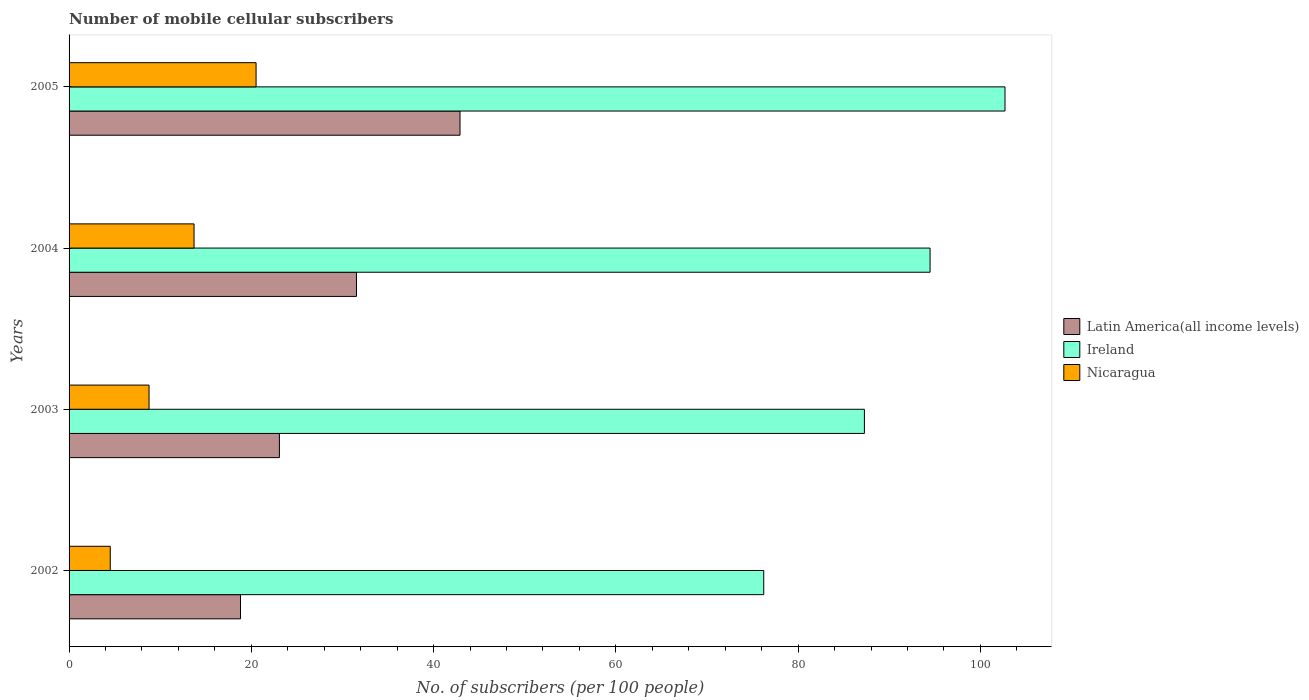How many groups of bars are there?
Make the answer very short. 4. How many bars are there on the 1st tick from the bottom?
Your answer should be very brief. 3. In how many cases, is the number of bars for a given year not equal to the number of legend labels?
Provide a short and direct response. 0. What is the number of mobile cellular subscribers in Nicaragua in 2004?
Keep it short and to the point. 13.71. Across all years, what is the maximum number of mobile cellular subscribers in Latin America(all income levels)?
Offer a very short reply. 42.9. Across all years, what is the minimum number of mobile cellular subscribers in Nicaragua?
Ensure brevity in your answer.  4.52. In which year was the number of mobile cellular subscribers in Ireland minimum?
Your answer should be compact. 2002. What is the total number of mobile cellular subscribers in Ireland in the graph?
Your answer should be very brief. 360.66. What is the difference between the number of mobile cellular subscribers in Nicaragua in 2002 and that in 2003?
Keep it short and to the point. -4.26. What is the difference between the number of mobile cellular subscribers in Latin America(all income levels) in 2004 and the number of mobile cellular subscribers in Ireland in 2003?
Ensure brevity in your answer.  -55.73. What is the average number of mobile cellular subscribers in Nicaragua per year?
Your answer should be very brief. 11.88. In the year 2004, what is the difference between the number of mobile cellular subscribers in Nicaragua and number of mobile cellular subscribers in Ireland?
Offer a terse response. -80.76. In how many years, is the number of mobile cellular subscribers in Ireland greater than 92 ?
Provide a succinct answer. 2. What is the ratio of the number of mobile cellular subscribers in Nicaragua in 2003 to that in 2005?
Your answer should be very brief. 0.43. Is the number of mobile cellular subscribers in Latin America(all income levels) in 2004 less than that in 2005?
Offer a very short reply. Yes. What is the difference between the highest and the second highest number of mobile cellular subscribers in Nicaragua?
Provide a succinct answer. 6.81. What is the difference between the highest and the lowest number of mobile cellular subscribers in Ireland?
Offer a terse response. 26.47. In how many years, is the number of mobile cellular subscribers in Latin America(all income levels) greater than the average number of mobile cellular subscribers in Latin America(all income levels) taken over all years?
Offer a very short reply. 2. Is the sum of the number of mobile cellular subscribers in Latin America(all income levels) in 2002 and 2004 greater than the maximum number of mobile cellular subscribers in Ireland across all years?
Provide a succinct answer. No. What does the 1st bar from the top in 2003 represents?
Offer a very short reply. Nicaragua. What does the 1st bar from the bottom in 2003 represents?
Offer a very short reply. Latin America(all income levels). Are all the bars in the graph horizontal?
Give a very brief answer. Yes. How many years are there in the graph?
Your answer should be compact. 4. Does the graph contain any zero values?
Provide a short and direct response. No. How many legend labels are there?
Ensure brevity in your answer.  3. How are the legend labels stacked?
Ensure brevity in your answer.  Vertical. What is the title of the graph?
Keep it short and to the point. Number of mobile cellular subscribers. What is the label or title of the X-axis?
Provide a short and direct response. No. of subscribers (per 100 people). What is the label or title of the Y-axis?
Keep it short and to the point. Years. What is the No. of subscribers (per 100 people) in Latin America(all income levels) in 2002?
Give a very brief answer. 18.81. What is the No. of subscribers (per 100 people) of Ireland in 2002?
Provide a succinct answer. 76.22. What is the No. of subscribers (per 100 people) in Nicaragua in 2002?
Provide a short and direct response. 4.52. What is the No. of subscribers (per 100 people) of Latin America(all income levels) in 2003?
Offer a terse response. 23.08. What is the No. of subscribers (per 100 people) of Ireland in 2003?
Ensure brevity in your answer.  87.27. What is the No. of subscribers (per 100 people) in Nicaragua in 2003?
Offer a terse response. 8.78. What is the No. of subscribers (per 100 people) in Latin America(all income levels) in 2004?
Give a very brief answer. 31.54. What is the No. of subscribers (per 100 people) in Ireland in 2004?
Provide a short and direct response. 94.47. What is the No. of subscribers (per 100 people) in Nicaragua in 2004?
Offer a terse response. 13.71. What is the No. of subscribers (per 100 people) in Latin America(all income levels) in 2005?
Your answer should be very brief. 42.9. What is the No. of subscribers (per 100 people) in Ireland in 2005?
Make the answer very short. 102.69. What is the No. of subscribers (per 100 people) in Nicaragua in 2005?
Provide a short and direct response. 20.52. Across all years, what is the maximum No. of subscribers (per 100 people) of Latin America(all income levels)?
Provide a succinct answer. 42.9. Across all years, what is the maximum No. of subscribers (per 100 people) of Ireland?
Your answer should be compact. 102.69. Across all years, what is the maximum No. of subscribers (per 100 people) in Nicaragua?
Provide a succinct answer. 20.52. Across all years, what is the minimum No. of subscribers (per 100 people) in Latin America(all income levels)?
Your answer should be very brief. 18.81. Across all years, what is the minimum No. of subscribers (per 100 people) of Ireland?
Provide a short and direct response. 76.22. Across all years, what is the minimum No. of subscribers (per 100 people) of Nicaragua?
Offer a very short reply. 4.52. What is the total No. of subscribers (per 100 people) in Latin America(all income levels) in the graph?
Provide a short and direct response. 116.32. What is the total No. of subscribers (per 100 people) in Ireland in the graph?
Your answer should be compact. 360.66. What is the total No. of subscribers (per 100 people) of Nicaragua in the graph?
Your answer should be compact. 47.53. What is the difference between the No. of subscribers (per 100 people) of Latin America(all income levels) in 2002 and that in 2003?
Your answer should be compact. -4.27. What is the difference between the No. of subscribers (per 100 people) of Ireland in 2002 and that in 2003?
Keep it short and to the point. -11.05. What is the difference between the No. of subscribers (per 100 people) of Nicaragua in 2002 and that in 2003?
Ensure brevity in your answer.  -4.26. What is the difference between the No. of subscribers (per 100 people) in Latin America(all income levels) in 2002 and that in 2004?
Your answer should be compact. -12.73. What is the difference between the No. of subscribers (per 100 people) of Ireland in 2002 and that in 2004?
Your answer should be compact. -18.25. What is the difference between the No. of subscribers (per 100 people) of Nicaragua in 2002 and that in 2004?
Give a very brief answer. -9.19. What is the difference between the No. of subscribers (per 100 people) of Latin America(all income levels) in 2002 and that in 2005?
Make the answer very short. -24.09. What is the difference between the No. of subscribers (per 100 people) of Ireland in 2002 and that in 2005?
Ensure brevity in your answer.  -26.47. What is the difference between the No. of subscribers (per 100 people) of Nicaragua in 2002 and that in 2005?
Give a very brief answer. -16. What is the difference between the No. of subscribers (per 100 people) in Latin America(all income levels) in 2003 and that in 2004?
Your answer should be compact. -8.46. What is the difference between the No. of subscribers (per 100 people) in Ireland in 2003 and that in 2004?
Offer a terse response. -7.21. What is the difference between the No. of subscribers (per 100 people) in Nicaragua in 2003 and that in 2004?
Keep it short and to the point. -4.94. What is the difference between the No. of subscribers (per 100 people) in Latin America(all income levels) in 2003 and that in 2005?
Offer a terse response. -19.82. What is the difference between the No. of subscribers (per 100 people) in Ireland in 2003 and that in 2005?
Your answer should be compact. -15.43. What is the difference between the No. of subscribers (per 100 people) of Nicaragua in 2003 and that in 2005?
Offer a very short reply. -11.74. What is the difference between the No. of subscribers (per 100 people) in Latin America(all income levels) in 2004 and that in 2005?
Provide a succinct answer. -11.36. What is the difference between the No. of subscribers (per 100 people) of Ireland in 2004 and that in 2005?
Provide a succinct answer. -8.22. What is the difference between the No. of subscribers (per 100 people) of Nicaragua in 2004 and that in 2005?
Give a very brief answer. -6.81. What is the difference between the No. of subscribers (per 100 people) in Latin America(all income levels) in 2002 and the No. of subscribers (per 100 people) in Ireland in 2003?
Your response must be concise. -68.46. What is the difference between the No. of subscribers (per 100 people) in Latin America(all income levels) in 2002 and the No. of subscribers (per 100 people) in Nicaragua in 2003?
Give a very brief answer. 10.03. What is the difference between the No. of subscribers (per 100 people) in Ireland in 2002 and the No. of subscribers (per 100 people) in Nicaragua in 2003?
Offer a terse response. 67.45. What is the difference between the No. of subscribers (per 100 people) of Latin America(all income levels) in 2002 and the No. of subscribers (per 100 people) of Ireland in 2004?
Your response must be concise. -75.66. What is the difference between the No. of subscribers (per 100 people) in Latin America(all income levels) in 2002 and the No. of subscribers (per 100 people) in Nicaragua in 2004?
Your response must be concise. 5.1. What is the difference between the No. of subscribers (per 100 people) of Ireland in 2002 and the No. of subscribers (per 100 people) of Nicaragua in 2004?
Your answer should be compact. 62.51. What is the difference between the No. of subscribers (per 100 people) in Latin America(all income levels) in 2002 and the No. of subscribers (per 100 people) in Ireland in 2005?
Give a very brief answer. -83.88. What is the difference between the No. of subscribers (per 100 people) of Latin America(all income levels) in 2002 and the No. of subscribers (per 100 people) of Nicaragua in 2005?
Give a very brief answer. -1.71. What is the difference between the No. of subscribers (per 100 people) in Ireland in 2002 and the No. of subscribers (per 100 people) in Nicaragua in 2005?
Offer a terse response. 55.7. What is the difference between the No. of subscribers (per 100 people) in Latin America(all income levels) in 2003 and the No. of subscribers (per 100 people) in Ireland in 2004?
Provide a succinct answer. -71.39. What is the difference between the No. of subscribers (per 100 people) in Latin America(all income levels) in 2003 and the No. of subscribers (per 100 people) in Nicaragua in 2004?
Offer a very short reply. 9.37. What is the difference between the No. of subscribers (per 100 people) in Ireland in 2003 and the No. of subscribers (per 100 people) in Nicaragua in 2004?
Provide a succinct answer. 73.55. What is the difference between the No. of subscribers (per 100 people) of Latin America(all income levels) in 2003 and the No. of subscribers (per 100 people) of Ireland in 2005?
Give a very brief answer. -79.61. What is the difference between the No. of subscribers (per 100 people) of Latin America(all income levels) in 2003 and the No. of subscribers (per 100 people) of Nicaragua in 2005?
Your response must be concise. 2.56. What is the difference between the No. of subscribers (per 100 people) in Ireland in 2003 and the No. of subscribers (per 100 people) in Nicaragua in 2005?
Give a very brief answer. 66.75. What is the difference between the No. of subscribers (per 100 people) of Latin America(all income levels) in 2004 and the No. of subscribers (per 100 people) of Ireland in 2005?
Offer a very short reply. -71.16. What is the difference between the No. of subscribers (per 100 people) in Latin America(all income levels) in 2004 and the No. of subscribers (per 100 people) in Nicaragua in 2005?
Your response must be concise. 11.02. What is the difference between the No. of subscribers (per 100 people) in Ireland in 2004 and the No. of subscribers (per 100 people) in Nicaragua in 2005?
Your response must be concise. 73.95. What is the average No. of subscribers (per 100 people) of Latin America(all income levels) per year?
Your response must be concise. 29.08. What is the average No. of subscribers (per 100 people) in Ireland per year?
Give a very brief answer. 90.16. What is the average No. of subscribers (per 100 people) of Nicaragua per year?
Your answer should be compact. 11.88. In the year 2002, what is the difference between the No. of subscribers (per 100 people) in Latin America(all income levels) and No. of subscribers (per 100 people) in Ireland?
Offer a very short reply. -57.41. In the year 2002, what is the difference between the No. of subscribers (per 100 people) of Latin America(all income levels) and No. of subscribers (per 100 people) of Nicaragua?
Your answer should be compact. 14.29. In the year 2002, what is the difference between the No. of subscribers (per 100 people) in Ireland and No. of subscribers (per 100 people) in Nicaragua?
Offer a terse response. 71.7. In the year 2003, what is the difference between the No. of subscribers (per 100 people) in Latin America(all income levels) and No. of subscribers (per 100 people) in Ireland?
Offer a terse response. -64.19. In the year 2003, what is the difference between the No. of subscribers (per 100 people) of Latin America(all income levels) and No. of subscribers (per 100 people) of Nicaragua?
Offer a very short reply. 14.3. In the year 2003, what is the difference between the No. of subscribers (per 100 people) in Ireland and No. of subscribers (per 100 people) in Nicaragua?
Your response must be concise. 78.49. In the year 2004, what is the difference between the No. of subscribers (per 100 people) in Latin America(all income levels) and No. of subscribers (per 100 people) in Ireland?
Your response must be concise. -62.94. In the year 2004, what is the difference between the No. of subscribers (per 100 people) in Latin America(all income levels) and No. of subscribers (per 100 people) in Nicaragua?
Give a very brief answer. 17.82. In the year 2004, what is the difference between the No. of subscribers (per 100 people) of Ireland and No. of subscribers (per 100 people) of Nicaragua?
Make the answer very short. 80.76. In the year 2005, what is the difference between the No. of subscribers (per 100 people) in Latin America(all income levels) and No. of subscribers (per 100 people) in Ireland?
Provide a succinct answer. -59.8. In the year 2005, what is the difference between the No. of subscribers (per 100 people) in Latin America(all income levels) and No. of subscribers (per 100 people) in Nicaragua?
Your answer should be very brief. 22.38. In the year 2005, what is the difference between the No. of subscribers (per 100 people) of Ireland and No. of subscribers (per 100 people) of Nicaragua?
Your response must be concise. 82.17. What is the ratio of the No. of subscribers (per 100 people) of Latin America(all income levels) in 2002 to that in 2003?
Your answer should be compact. 0.81. What is the ratio of the No. of subscribers (per 100 people) in Ireland in 2002 to that in 2003?
Keep it short and to the point. 0.87. What is the ratio of the No. of subscribers (per 100 people) of Nicaragua in 2002 to that in 2003?
Offer a very short reply. 0.52. What is the ratio of the No. of subscribers (per 100 people) of Latin America(all income levels) in 2002 to that in 2004?
Make the answer very short. 0.6. What is the ratio of the No. of subscribers (per 100 people) of Ireland in 2002 to that in 2004?
Ensure brevity in your answer.  0.81. What is the ratio of the No. of subscribers (per 100 people) of Nicaragua in 2002 to that in 2004?
Provide a succinct answer. 0.33. What is the ratio of the No. of subscribers (per 100 people) in Latin America(all income levels) in 2002 to that in 2005?
Keep it short and to the point. 0.44. What is the ratio of the No. of subscribers (per 100 people) in Ireland in 2002 to that in 2005?
Your answer should be very brief. 0.74. What is the ratio of the No. of subscribers (per 100 people) in Nicaragua in 2002 to that in 2005?
Provide a short and direct response. 0.22. What is the ratio of the No. of subscribers (per 100 people) in Latin America(all income levels) in 2003 to that in 2004?
Make the answer very short. 0.73. What is the ratio of the No. of subscribers (per 100 people) of Ireland in 2003 to that in 2004?
Give a very brief answer. 0.92. What is the ratio of the No. of subscribers (per 100 people) in Nicaragua in 2003 to that in 2004?
Offer a terse response. 0.64. What is the ratio of the No. of subscribers (per 100 people) in Latin America(all income levels) in 2003 to that in 2005?
Provide a succinct answer. 0.54. What is the ratio of the No. of subscribers (per 100 people) of Ireland in 2003 to that in 2005?
Offer a terse response. 0.85. What is the ratio of the No. of subscribers (per 100 people) in Nicaragua in 2003 to that in 2005?
Offer a very short reply. 0.43. What is the ratio of the No. of subscribers (per 100 people) in Latin America(all income levels) in 2004 to that in 2005?
Make the answer very short. 0.74. What is the ratio of the No. of subscribers (per 100 people) in Ireland in 2004 to that in 2005?
Provide a short and direct response. 0.92. What is the ratio of the No. of subscribers (per 100 people) in Nicaragua in 2004 to that in 2005?
Give a very brief answer. 0.67. What is the difference between the highest and the second highest No. of subscribers (per 100 people) of Latin America(all income levels)?
Provide a succinct answer. 11.36. What is the difference between the highest and the second highest No. of subscribers (per 100 people) in Ireland?
Make the answer very short. 8.22. What is the difference between the highest and the second highest No. of subscribers (per 100 people) of Nicaragua?
Give a very brief answer. 6.81. What is the difference between the highest and the lowest No. of subscribers (per 100 people) of Latin America(all income levels)?
Offer a very short reply. 24.09. What is the difference between the highest and the lowest No. of subscribers (per 100 people) of Ireland?
Offer a very short reply. 26.47. What is the difference between the highest and the lowest No. of subscribers (per 100 people) of Nicaragua?
Give a very brief answer. 16. 